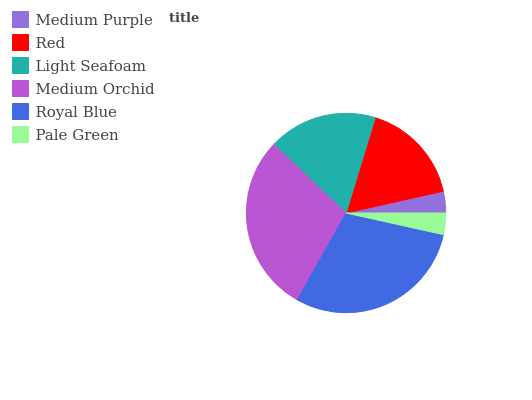Is Pale Green the minimum?
Answer yes or no. Yes. Is Royal Blue the maximum?
Answer yes or no. Yes. Is Red the minimum?
Answer yes or no. No. Is Red the maximum?
Answer yes or no. No. Is Red greater than Medium Purple?
Answer yes or no. Yes. Is Medium Purple less than Red?
Answer yes or no. Yes. Is Medium Purple greater than Red?
Answer yes or no. No. Is Red less than Medium Purple?
Answer yes or no. No. Is Light Seafoam the high median?
Answer yes or no. Yes. Is Red the low median?
Answer yes or no. Yes. Is Medium Orchid the high median?
Answer yes or no. No. Is Pale Green the low median?
Answer yes or no. No. 